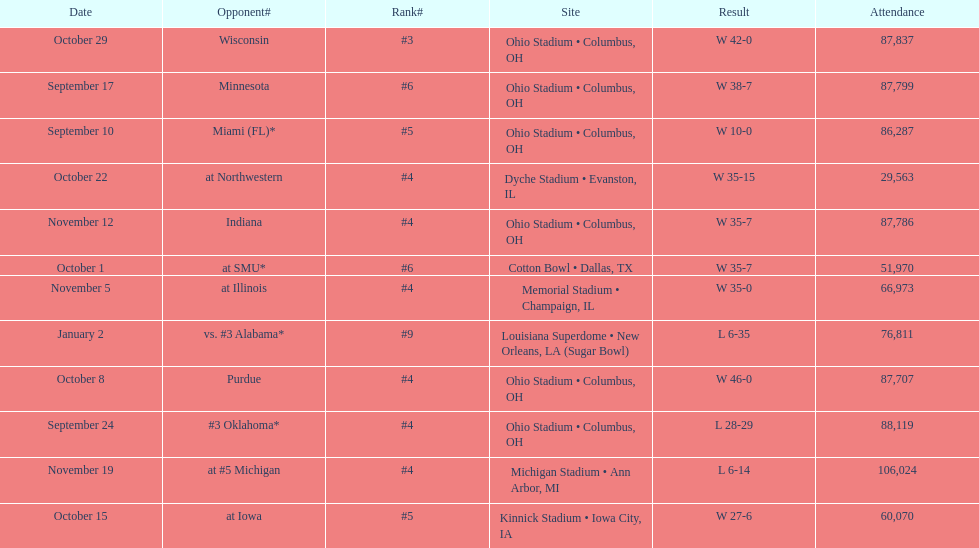Would you be able to parse every entry in this table? {'header': ['Date', 'Opponent#', 'Rank#', 'Site', 'Result', 'Attendance'], 'rows': [['October 29', 'Wisconsin', '#3', 'Ohio Stadium • Columbus, OH', 'W\xa042-0', '87,837'], ['September 17', 'Minnesota', '#6', 'Ohio Stadium • Columbus, OH', 'W\xa038-7', '87,799'], ['September 10', 'Miami (FL)*', '#5', 'Ohio Stadium • Columbus, OH', 'W\xa010-0', '86,287'], ['October 22', 'at\xa0Northwestern', '#4', 'Dyche Stadium • Evanston, IL', 'W\xa035-15', '29,563'], ['November 12', 'Indiana', '#4', 'Ohio Stadium • Columbus, OH', 'W\xa035-7', '87,786'], ['October 1', 'at\xa0SMU*', '#6', 'Cotton Bowl • Dallas, TX', 'W\xa035-7', '51,970'], ['November 5', 'at\xa0Illinois', '#4', 'Memorial Stadium • Champaign, IL', 'W\xa035-0', '66,973'], ['January 2', 'vs.\xa0#3\xa0Alabama*', '#9', 'Louisiana Superdome • New Orleans, LA (Sugar Bowl)', 'L\xa06-35', '76,811'], ['October 8', 'Purdue', '#4', 'Ohio Stadium • Columbus, OH', 'W\xa046-0', '87,707'], ['September 24', '#3\xa0Oklahoma*', '#4', 'Ohio Stadium • Columbus, OH', 'L\xa028-29', '88,119'], ['November 19', 'at\xa0#5\xa0Michigan', '#4', 'Michigan Stadium • Ann Arbor, MI', 'L\xa06-14', '106,024'], ['October 15', 'at\xa0Iowa', '#5', 'Kinnick Stadium • Iowa City, IA', 'W\xa027-6', '60,070']]} In how many games were than more than 80,000 people attending 7. 